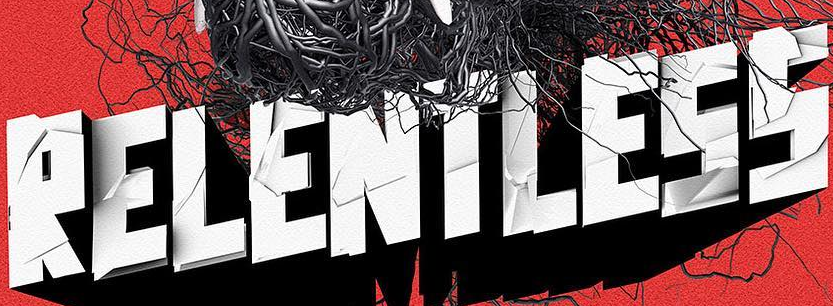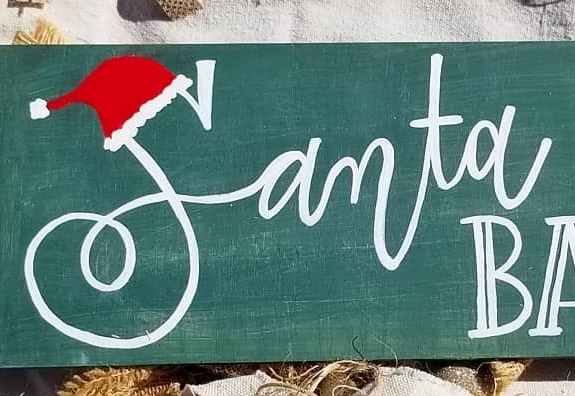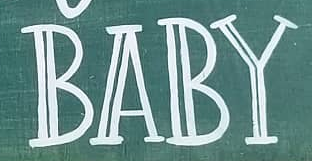What text is displayed in these images sequentially, separated by a semicolon? RELENTLESS; Samta; BABY 